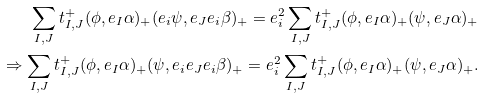<formula> <loc_0><loc_0><loc_500><loc_500>\sum _ { I , J } t ^ { + } _ { I , J } ( \phi , e _ { I } \alpha ) _ { + } ( e _ { i } \psi , e _ { J } e _ { i } \beta ) _ { + } = e _ { i } ^ { 2 } \sum _ { I , J } t ^ { + } _ { I , J } ( \phi , e _ { I } \alpha ) _ { + } ( \psi , e _ { J } \alpha ) _ { + } \\ \Rightarrow \sum _ { I , J } t ^ { + } _ { I , J } ( \phi , e _ { I } \alpha ) _ { + } ( \psi , e _ { i } e _ { J } e _ { i } \beta ) _ { + } = e _ { i } ^ { 2 } \sum _ { I , J } t ^ { + } _ { I , J } ( \phi , e _ { I } \alpha ) _ { + } ( \psi , e _ { J } \alpha ) _ { + } .</formula> 